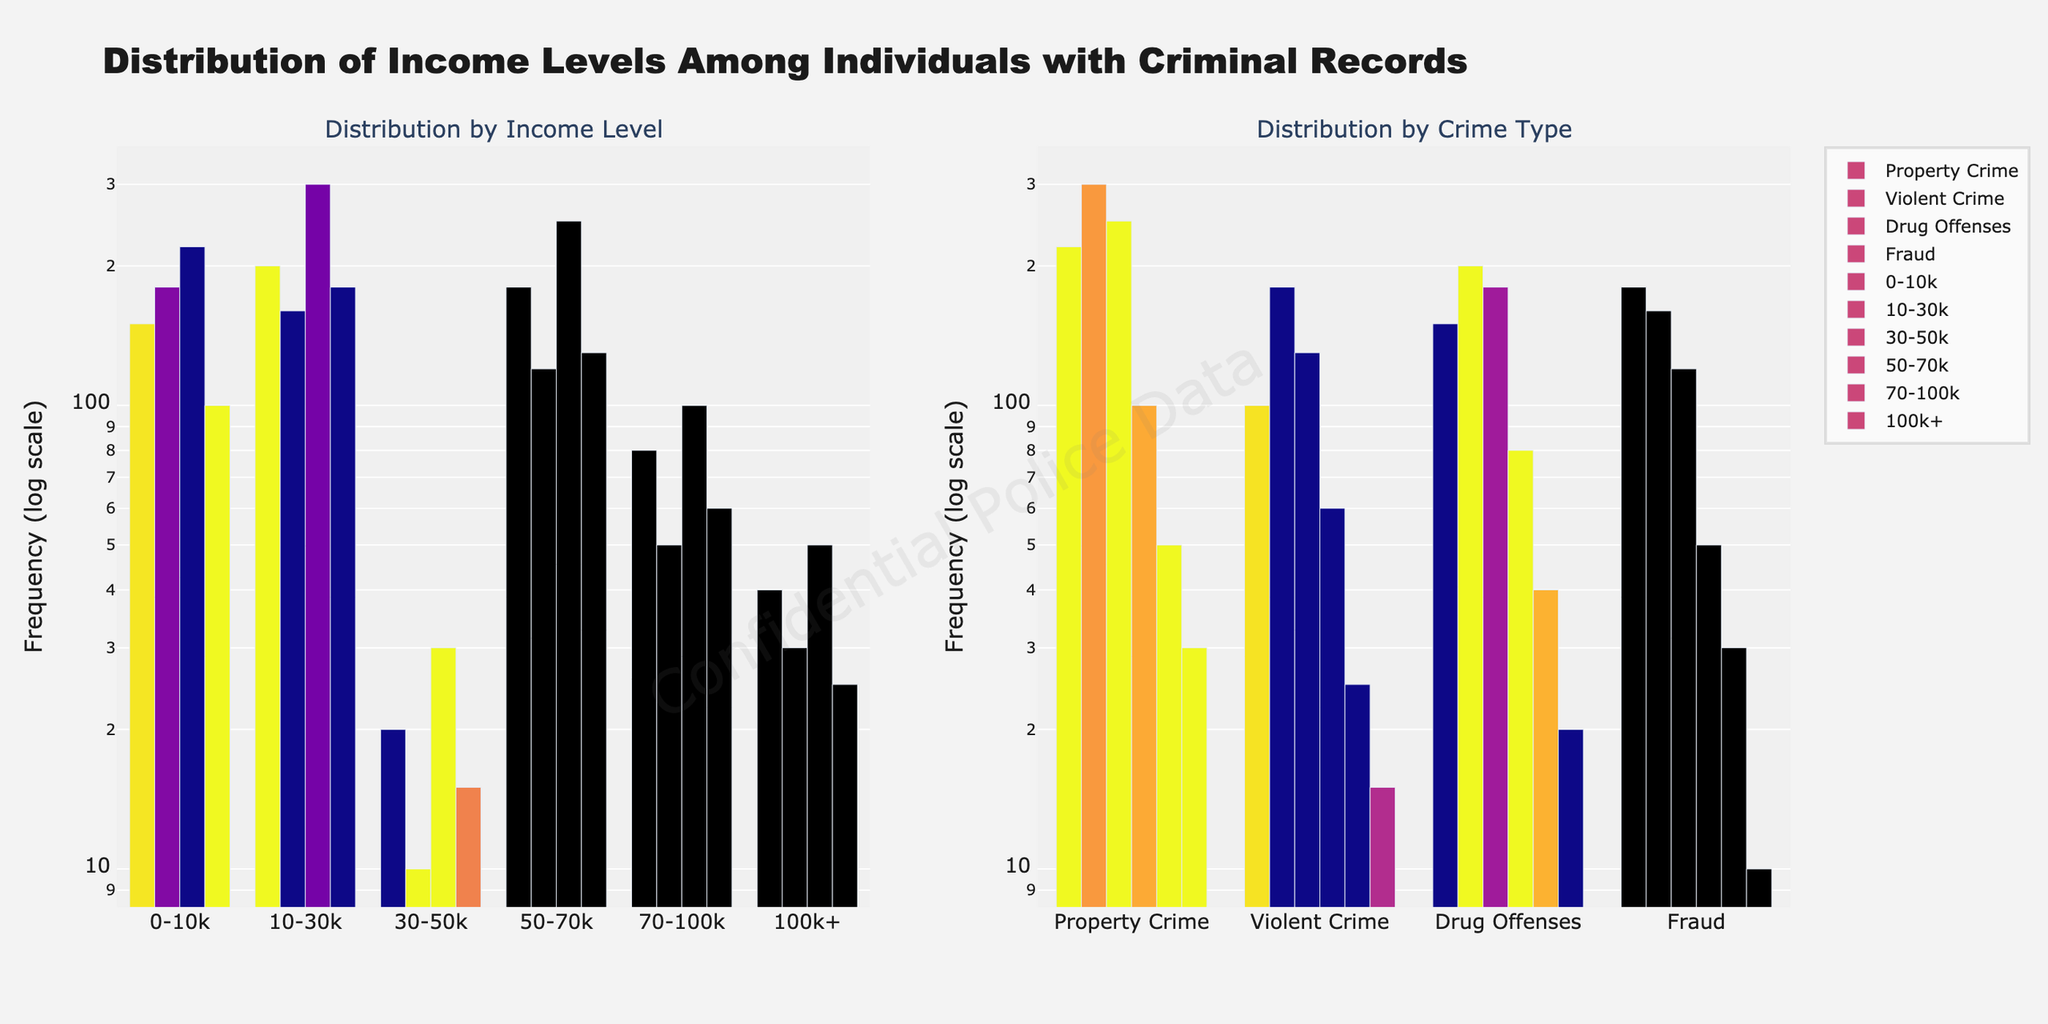what is the title of the figure? The title can be found at the top of the figure, which summarizes the content of the plot.
Answer: Distribution of Income Levels Among Individuals with Criminal Records Which crime type has the highest frequency in the income level 0-10k? To answer this, observe the bars corresponding to the 0-10k category in the plot on the left and identify the tallest one.
Answer: Drug Offenses Compare the frequencies of Drug Offenses and Fraud in the income level 70-100k. The frequencies can be seen as the heights of the respective bars in the 70-100k category on the left plot. Count the grid spacing as log scale is used.
Answer: 50 for Drug Offenses, 25 for Fraud Which income level has the lowest frequency of Violent Crime? Check the height of the bars for Violent Crime in each income level. The shortest bar represents the lowest frequency.
Answer: 100k+ What is the total frequency of Property Crime across all income levels? Sum the heights of the bars for Property Crime in each income level category on the left plot. On a log scale, interpret the y values and sum them up.
Answer: 150 + 200 + 180 + 80 + 40 + 20 = 670 Which type of crime shows a decrease in frequency as income levels increase? Observe the trend in bar heights for each crime type across the increasing income levels. Look for a consistently downward pattern.
Answer: Drug Offenses How do the frequencies of Property Crime and Violent Crime compare at the income level 30-50k? Compare the heights of the bars for Property Crime and Violent Crime in the 30-50k category on the left plot.
Answer: 180 for Property Crime, 120 for Violent Crime Between Fraud and Drug Offenses, which has a higher frequency in the income level 10-30k? Check the heights of the bars for Fraud and Drug Offenses in the 10-30k category on the left plot.
Answer: Drug Offenses Which income level has the highest frequency of Fraud? Identify the income level with the tallest bar for Fraud on the left plot.
Answer: 10-30k What can you infer about the trend of Drug Offenses frequency across different income levels from the log scale plot? Examine the height pattern of the bars for Drug Offenses across the income levels. The trend can be interpreted by looking at a consistent increase or decrease as income levels change.
Answer: Decreases as income levels increase 